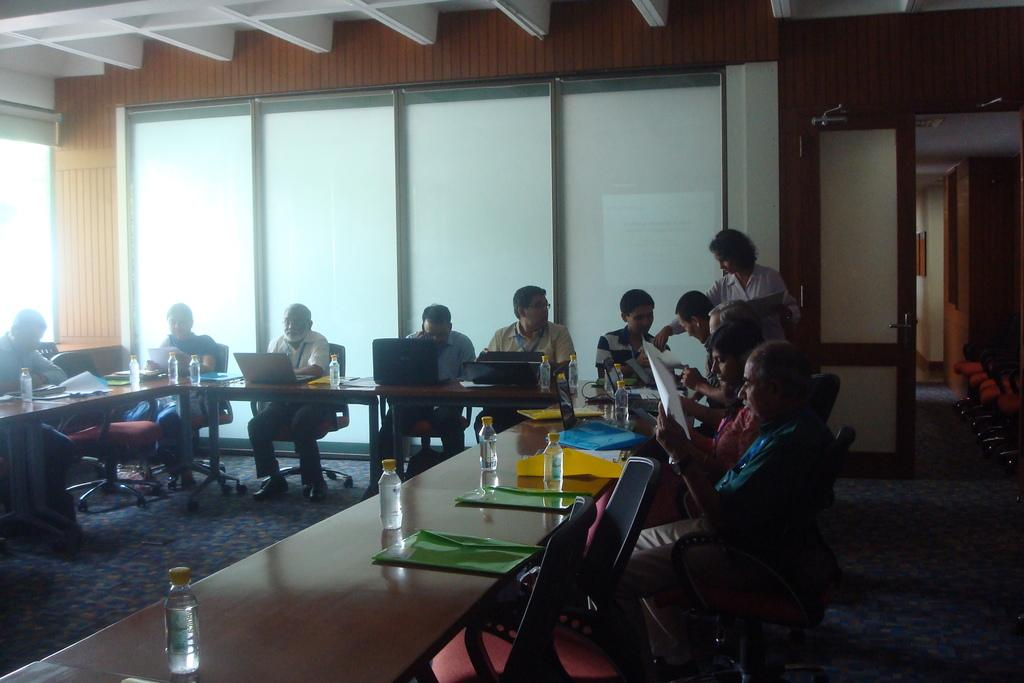What are the people in the image doing? The people in the image are sitting and working on laptops. Can you describe the setting in which the people are working? There is a glass door and a wooden wall in the background of the image. What type of peace symbol can be seen hanging from the wooden wall in the image? There is no peace symbol or any symbol hanging from the wooden wall in the image. What kind of badge is the person wearing in the image? There are no badges or any accessories visible on the people in the image. 